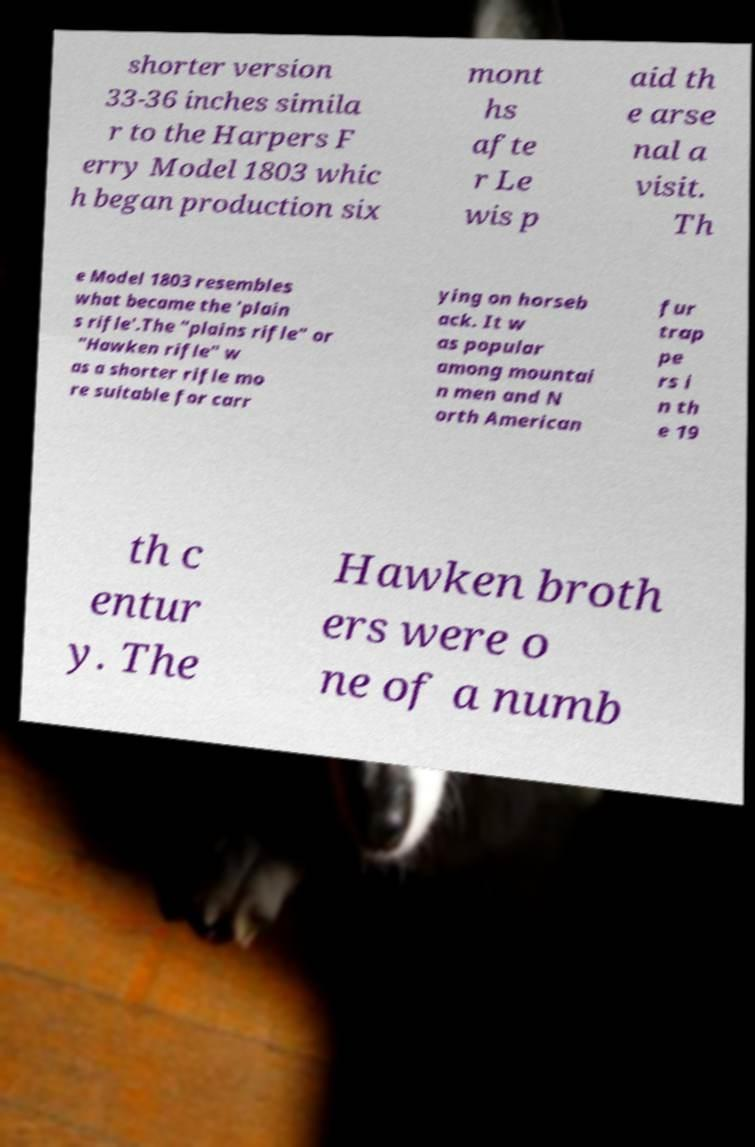For documentation purposes, I need the text within this image transcribed. Could you provide that? shorter version 33-36 inches simila r to the Harpers F erry Model 1803 whic h began production six mont hs afte r Le wis p aid th e arse nal a visit. Th e Model 1803 resembles what became the 'plain s rifle'.The "plains rifle" or "Hawken rifle" w as a shorter rifle mo re suitable for carr ying on horseb ack. It w as popular among mountai n men and N orth American fur trap pe rs i n th e 19 th c entur y. The Hawken broth ers were o ne of a numb 